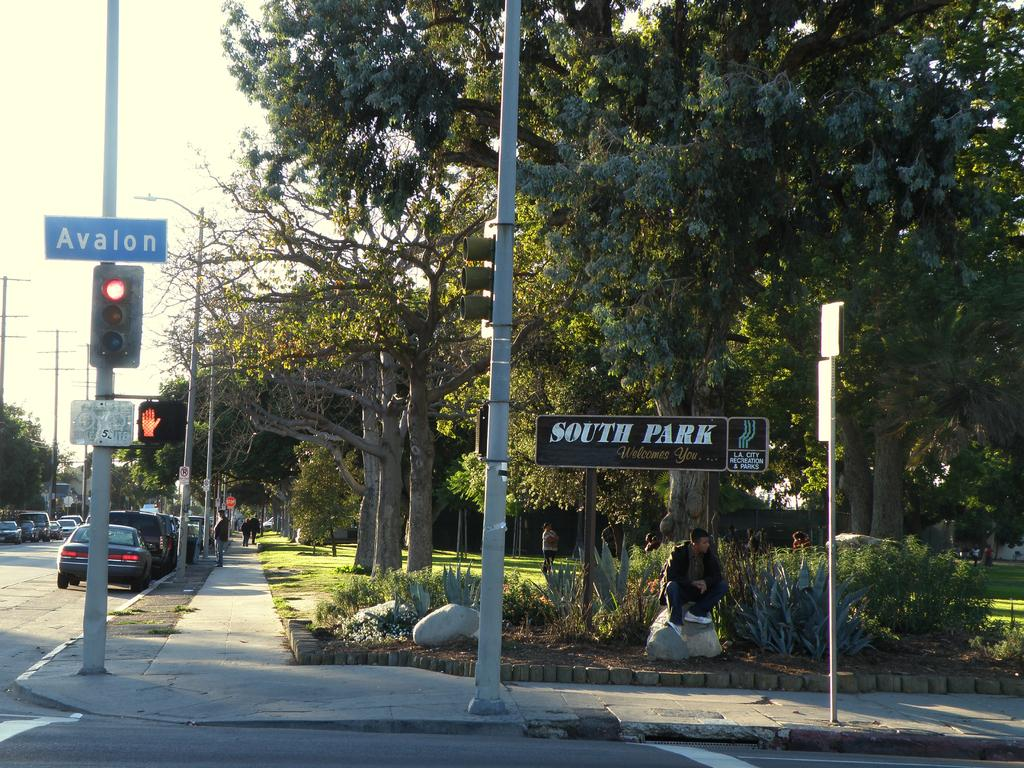Provide a one-sentence caption for the provided image. A man is sitting under a sign that welcomes you to South Park. 